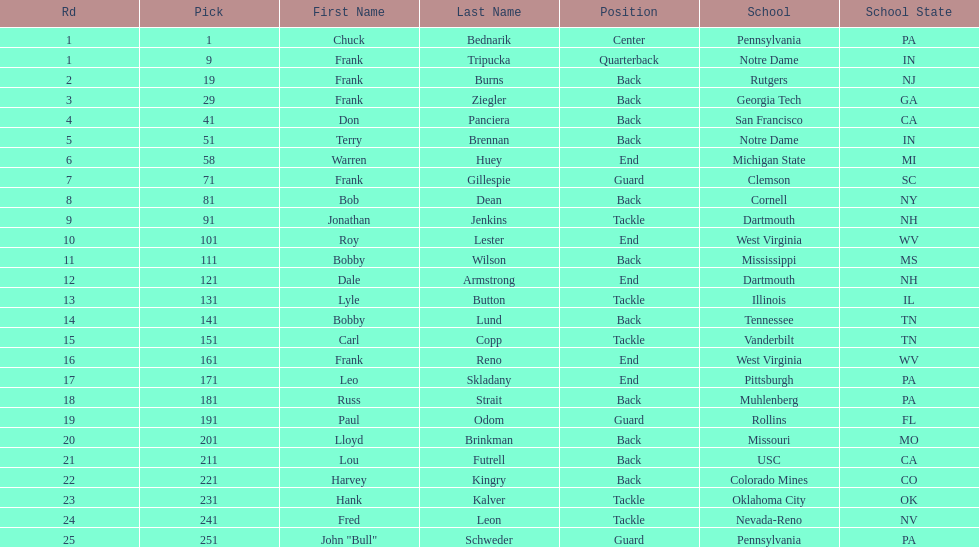Can you parse all the data within this table? {'header': ['Rd', 'Pick', 'First Name', 'Last Name', 'Position', 'School', 'School State'], 'rows': [['1', '1', 'Chuck', 'Bednarik', 'Center', 'Pennsylvania', 'PA'], ['1', '9', 'Frank', 'Tripucka', 'Quarterback', 'Notre Dame', 'IN'], ['2', '19', 'Frank', 'Burns', 'Back', 'Rutgers', 'NJ'], ['3', '29', 'Frank', 'Ziegler', 'Back', 'Georgia Tech', 'GA'], ['4', '41', 'Don', 'Panciera', 'Back', 'San Francisco', 'CA'], ['5', '51', 'Terry', 'Brennan', 'Back', 'Notre Dame', 'IN'], ['6', '58', 'Warren', 'Huey', 'End', 'Michigan State', 'MI'], ['7', '71', 'Frank', 'Gillespie', 'Guard', 'Clemson', 'SC'], ['8', '81', 'Bob', 'Dean', 'Back', 'Cornell', 'NY'], ['9', '91', 'Jonathan', 'Jenkins', 'Tackle', 'Dartmouth', 'NH'], ['10', '101', 'Roy', 'Lester', 'End', 'West Virginia', 'WV'], ['11', '111', 'Bobby', 'Wilson', 'Back', 'Mississippi', 'MS'], ['12', '121', 'Dale', 'Armstrong', 'End', 'Dartmouth', 'NH'], ['13', '131', 'Lyle', 'Button', 'Tackle', 'Illinois', 'IL'], ['14', '141', 'Bobby', 'Lund', 'Back', 'Tennessee', 'TN'], ['15', '151', 'Carl', 'Copp', 'Tackle', 'Vanderbilt', 'TN'], ['16', '161', 'Frank', 'Reno', 'End', 'West Virginia', 'WV'], ['17', '171', 'Leo', 'Skladany', 'End', 'Pittsburgh', 'PA'], ['18', '181', 'Russ', 'Strait', 'Back', 'Muhlenberg', 'PA'], ['19', '191', 'Paul', 'Odom', 'Guard', 'Rollins', 'FL'], ['20', '201', 'Lloyd', 'Brinkman', 'Back', 'Missouri', 'MO'], ['21', '211', 'Lou', 'Futrell', 'Back', 'USC', 'CA'], ['22', '221', 'Harvey', 'Kingry', 'Back', 'Colorado Mines', 'CO'], ['23', '231', 'Hank', 'Kalver', 'Tackle', 'Oklahoma City', 'OK'], ['24', '241', 'Fred', 'Leon', 'Tackle', 'Nevada-Reno', 'NV'], ['25', '251', 'John "Bull"', 'Schweder', 'Guard', 'Pennsylvania', 'PA']]} How many players were from notre dame? 2. 